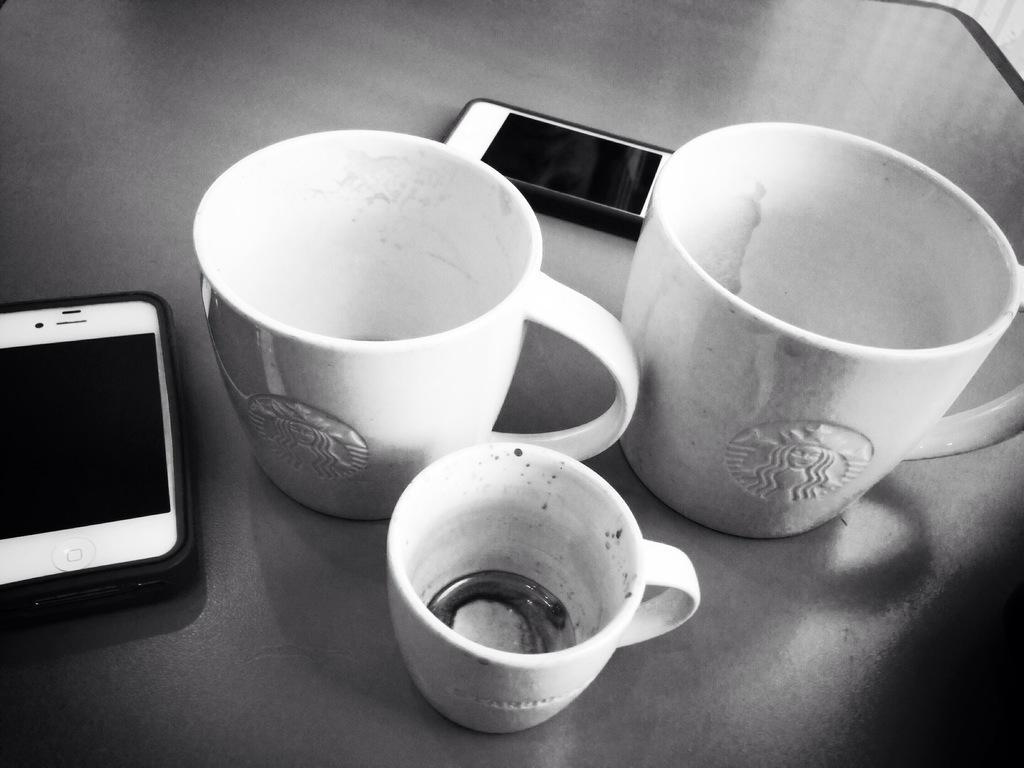How would you summarize this image in a sentence or two? In this picture there are three cups and two mobile phones. 